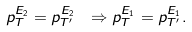<formula> <loc_0><loc_0><loc_500><loc_500>p _ { T } ^ { E _ { 2 } } = p _ { T ^ { \prime } } ^ { E _ { 2 } } \ \Rightarrow p _ { T } ^ { E _ { 1 } } = p _ { T ^ { \prime } } ^ { E _ { 1 } } .</formula> 